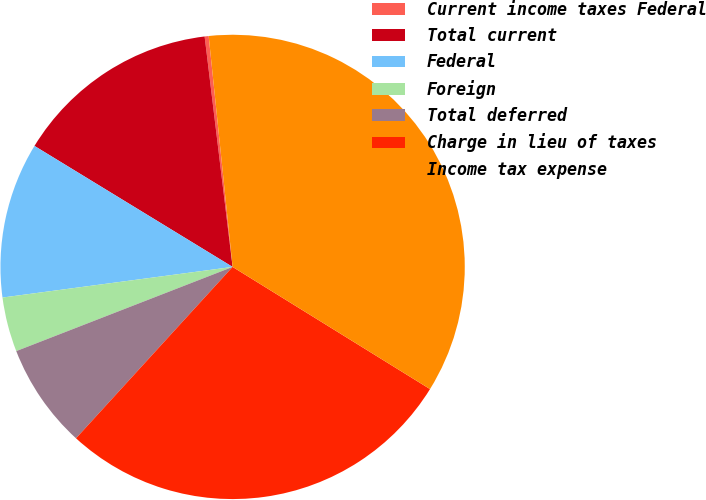<chart> <loc_0><loc_0><loc_500><loc_500><pie_chart><fcel>Current income taxes Federal<fcel>Total current<fcel>Federal<fcel>Foreign<fcel>Total deferred<fcel>Charge in lieu of taxes<fcel>Income tax expense<nl><fcel>0.28%<fcel>14.35%<fcel>10.83%<fcel>3.8%<fcel>7.31%<fcel>27.96%<fcel>35.46%<nl></chart> 